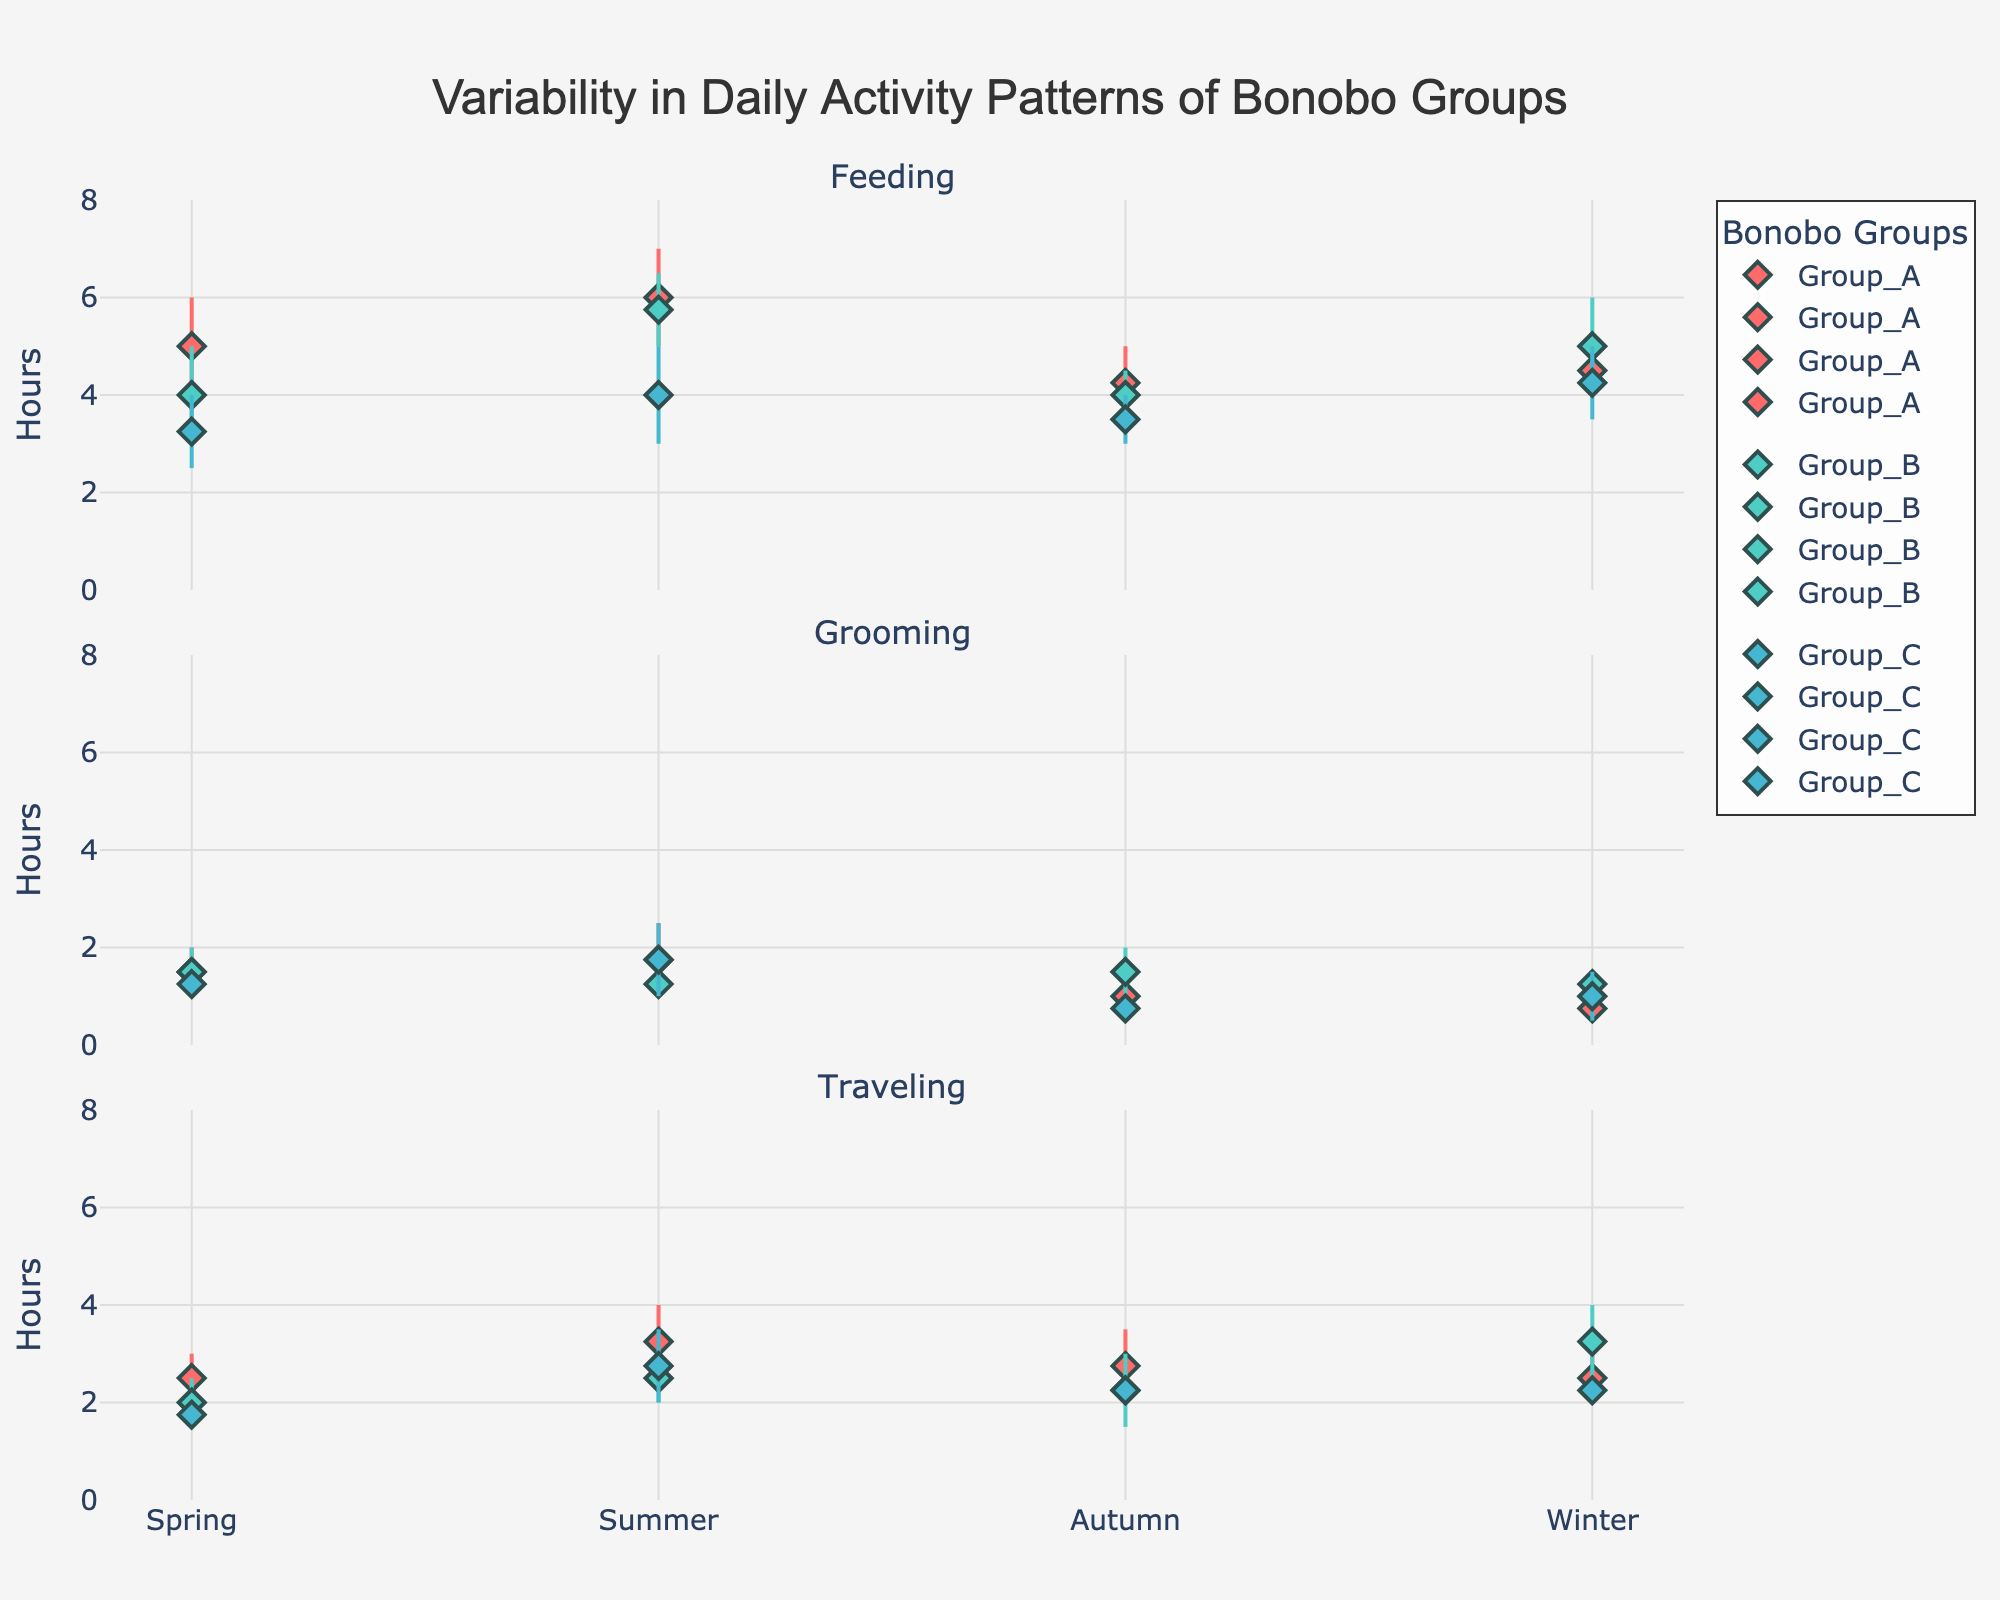What is the title of the figure? The title is usually found at the top of the figure. In this case, it is centered and prominently displayed.
Answer: Variability in Daily Activity Patterns of Bonobo Groups How many activities are displayed in the plot? The plot has subplots titled by each activity; counting these gives the total number of activities.
Answer: 3 Which group has the largest variability in feeding during the summer? To determine this, look at the range (difference between max and min hours) of feeding activity for each group in summer. Group A ranges from 5 to 7 hours (2 hours), Group B from 5 to 6.5 hours (1.5 hours), and Group C from 3 to 5 hours (2 hours). Groups A and C have the same largest variability of 2 hours, but considering uniqueness makes Group A stand out.
Answer: Group A Which season shows the least variability in grooming for Group C? To find this, look at the error bars for grooming activity for Group C across different seasons. The smallest error bars indicate the least variability.
Answer: Autumn In which season do Group B bonobos spend the most time traveling, on average? To find the average traveling time, calculate the midpoint between the min and max hours for each season for Group B, then compare these values. In summer, the range is 2 to 3 hours with a midpoint of 2.5 hours. In winter, the range is 2.5 to 4 hours with a midpoint of 3.25 hours, which is the highest.
Answer: Winter Which activity in Group A has the greatest consistency in hours across all seasons? Consistency can be inferred from the smallest range or least variation in the min and max hours for each activity across all seasons for Group A. Comparing feeding, grooming, and traveling, grooming shows the least variation (between 0.5 and 2.5 hours).
Answer: Grooming What is the average maximum hours of feeding for Group C across all seasons? To find this, sum the maximum hours of feeding for Group C for each season and divide by the number of seasons. (4 + 5 + 4 + 5) / 4 = 4.5
Answer: 4.5 hours Which season shows the highest max hours spent by any group in grooming? To determine this, compare all maximum values for grooming from each group across all seasons. Summer for Group A has the highest max hours at 2.5 hours.
Answer: Summer 